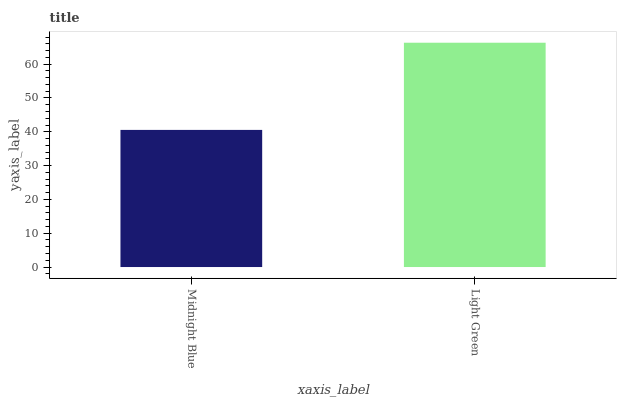Is Midnight Blue the minimum?
Answer yes or no. Yes. Is Light Green the maximum?
Answer yes or no. Yes. Is Light Green the minimum?
Answer yes or no. No. Is Light Green greater than Midnight Blue?
Answer yes or no. Yes. Is Midnight Blue less than Light Green?
Answer yes or no. Yes. Is Midnight Blue greater than Light Green?
Answer yes or no. No. Is Light Green less than Midnight Blue?
Answer yes or no. No. Is Light Green the high median?
Answer yes or no. Yes. Is Midnight Blue the low median?
Answer yes or no. Yes. Is Midnight Blue the high median?
Answer yes or no. No. Is Light Green the low median?
Answer yes or no. No. 